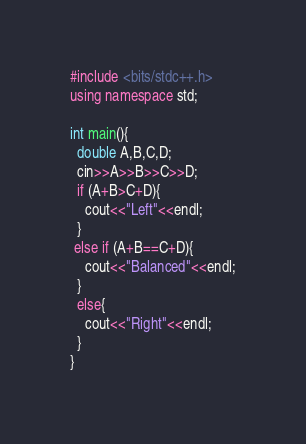<code> <loc_0><loc_0><loc_500><loc_500><_C++_>#include <bits/stdc++.h>
using namespace std;

int main(){
  double A,B,C,D;
  cin>>A>>B>>C>>D;
  if (A+B>C+D){
    cout<<"Left"<<endl;
  }
 else if (A+B==C+D){
    cout<<"Balanced"<<endl;
  }
  else{
    cout<<"Right"<<endl;
  }
}</code> 